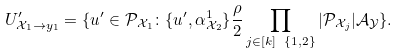Convert formula to latex. <formula><loc_0><loc_0><loc_500><loc_500>U ^ { \prime } _ { \mathcal { X } _ { 1 } \to y _ { 1 } } = \{ u ^ { \prime } \in \mathcal { P } _ { \mathcal { X } _ { 1 } } \colon \{ u ^ { \prime } , \alpha ^ { 1 } _ { \mathcal { X } _ { 2 } } \} \frac { \rho } { 2 } \prod _ { j \in [ k ] \ \{ 1 , 2 \} } | \mathcal { P } _ { \mathcal { X } _ { j } } | \mathcal { A } _ { \mathcal { Y } } \} .</formula> 